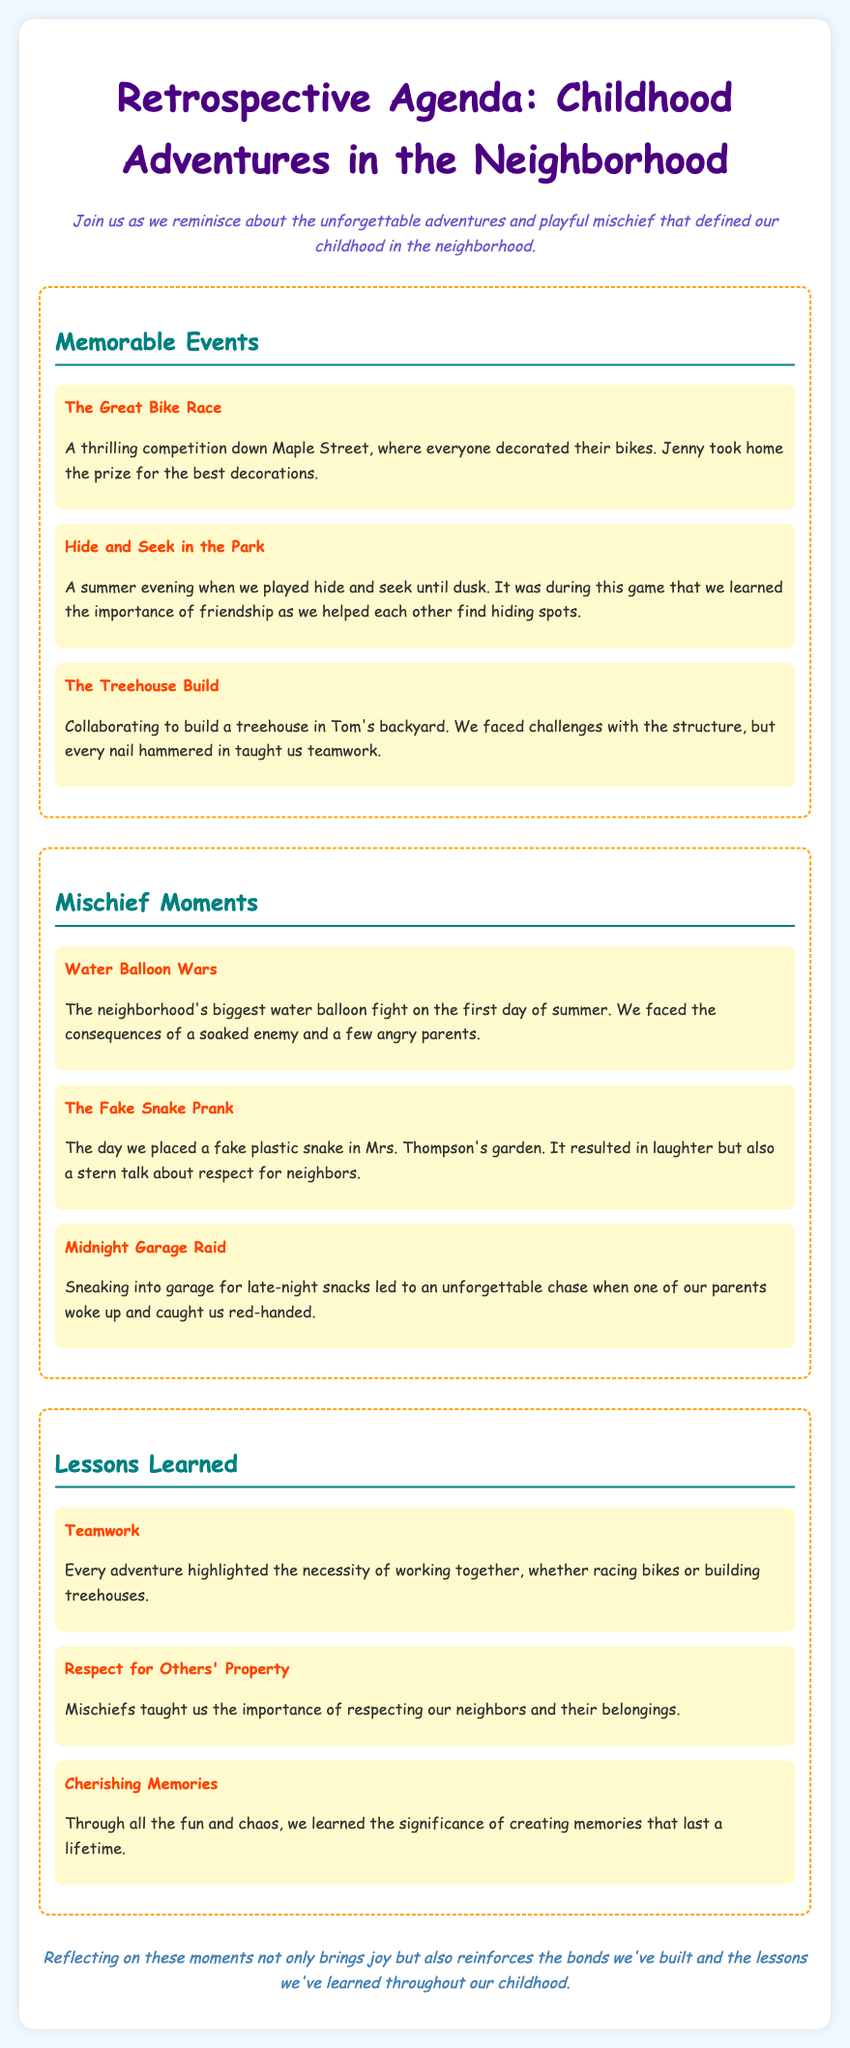What is the title of the document? The title is stated in the <title> tag of the document, which is "Childhood Adventures Retrospective."
Answer: Childhood Adventures Retrospective Who won the prize for the best bike decorations? The name associated with the prize is mentioned in the event description of "The Great Bike Race."
Answer: Jenny What game did the neighborhood kids play until dusk? The specific game played is highlighted in the "Hide and Seek in the Park" section.
Answer: Hide and Seek What was built in Tom's backyard? This is a specific item mentioned in the "The Treehouse Build" section of the agenda.
Answer: Treehouse How many mischief moments are listed in the document? The total number of mischief moments is present in the section detailing them, specifically counting the items.
Answer: Three Which lesson emphasizes working together? This lesson is directly mentioned in the "Lessons Learned" section, specifically tied to teamwork.
Answer: Teamwork What did the plastic snake prank result in? The outcome of the prank is referenced in the description of the "The Fake Snake Prank."
Answer: Laughter What color is the header text for the lessons learned section? The color used for the header text of each section can be found in the style rules defined, describing its styling characteristics.
Answer: Teal 